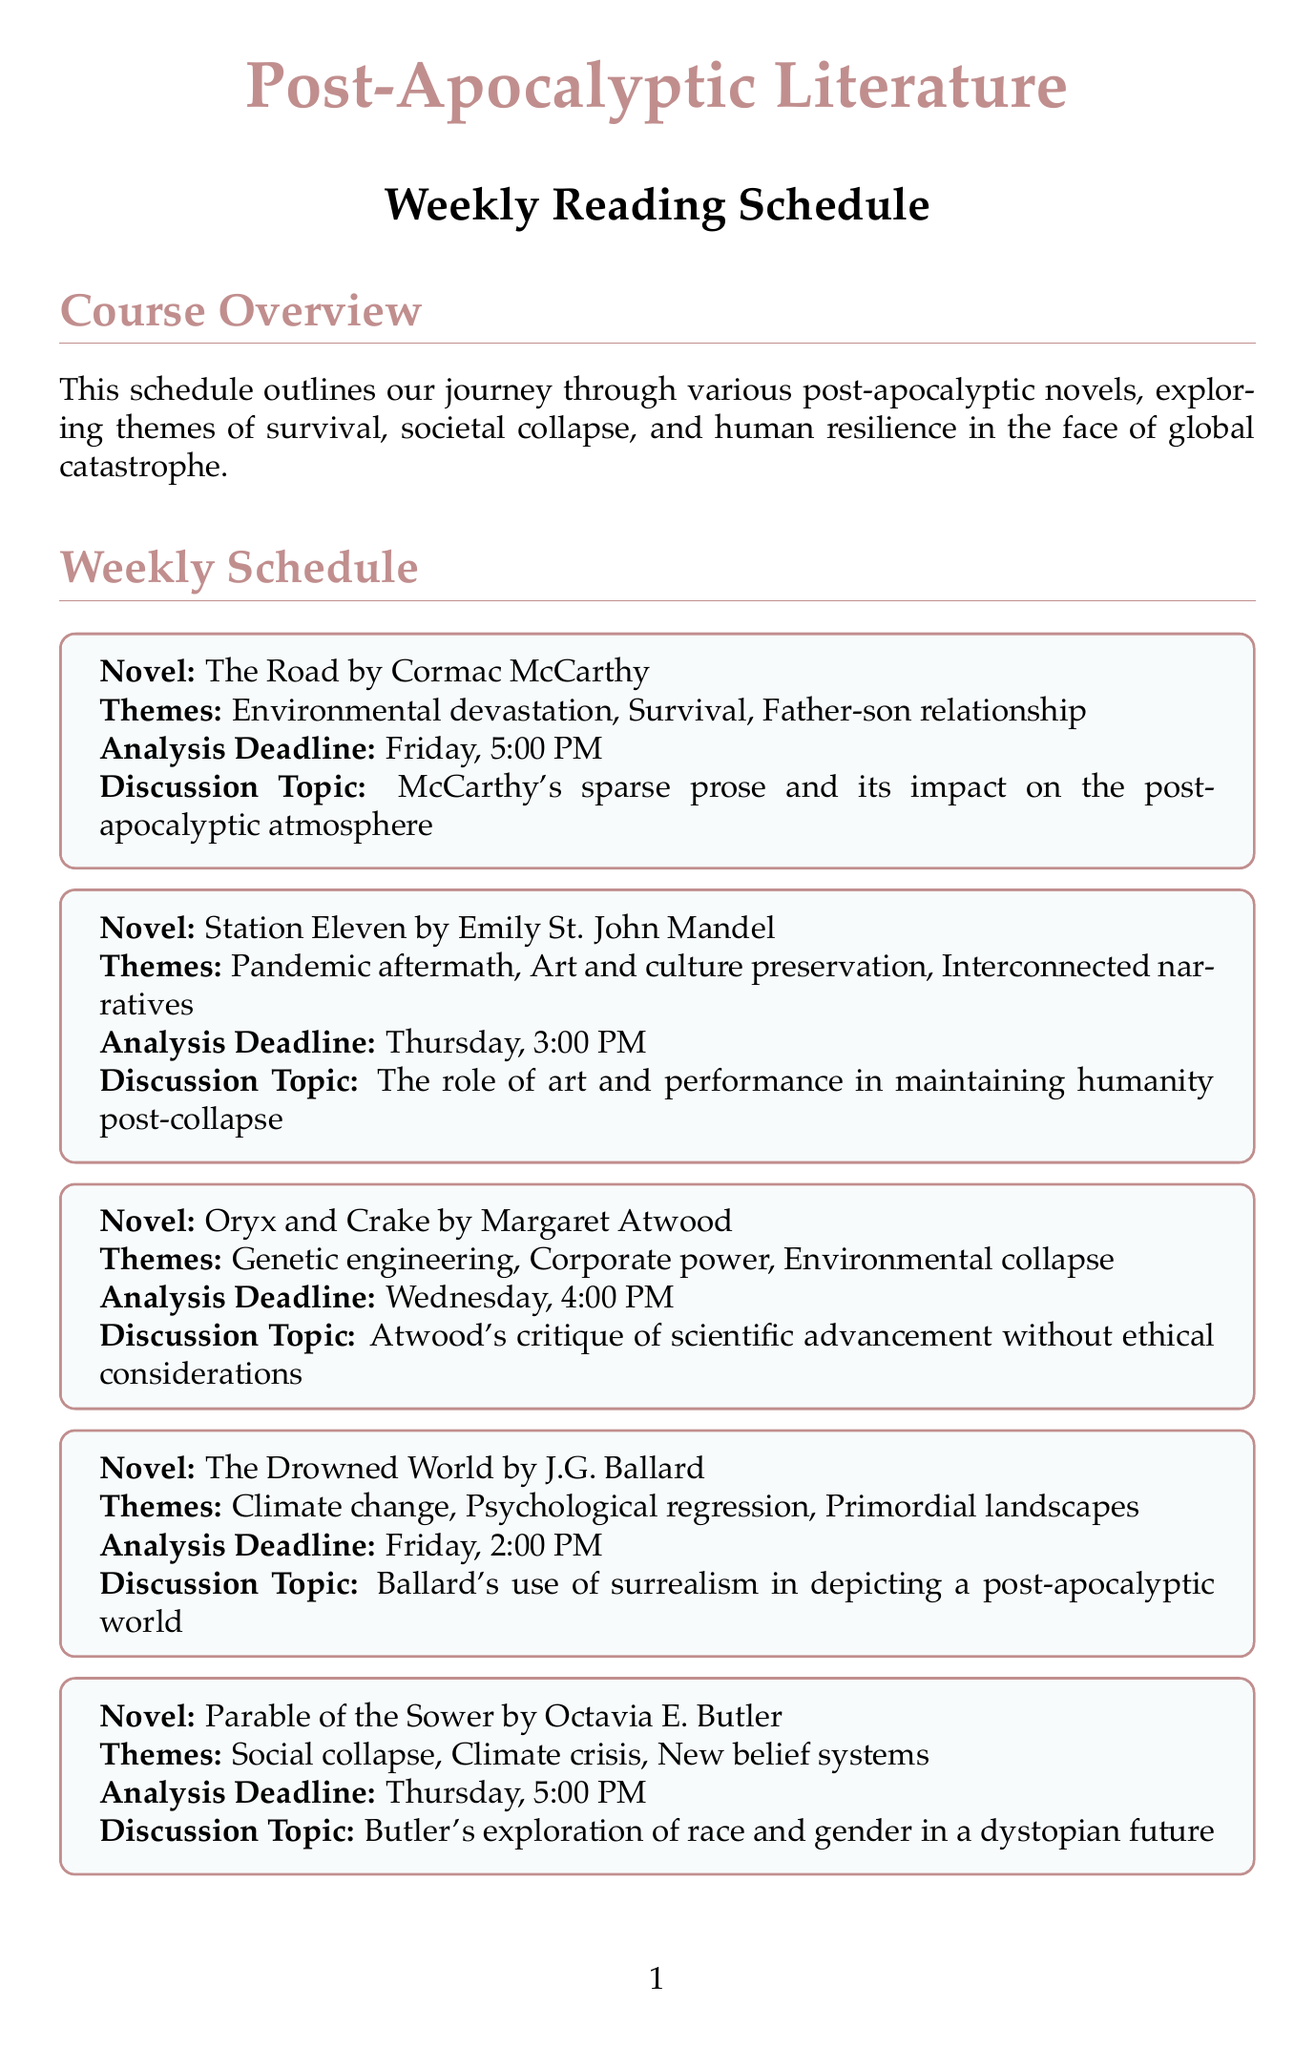what novel is assigned for week 1? The document lists "The Road by Cormac McCarthy" as the novel for week 1.
Answer: The Road by Cormac McCarthy what is the analysis deadline for "Station Eleven"? The document specifies that the analysis deadline for "Station Eleven" is Thursday, 3:00 PM.
Answer: Thursday, 3:00 PM which theme is associated with "The Handmaid's Tale"? "The Handmaid's Tale" is associated with themes such as gender oppression, religious extremism, and reproductive rights.
Answer: Gender oppression what is the discussion topic for "The Chrysalids"? The discussion topic listed for "The Chrysalids" is about Wyndham's exploration of prejudice and evolution in a post-nuclear world.
Answer: Wyndham's exploration of prejudice and evolution in a post-nuclear world how many novels are listed in the weekly reading schedule? The document contains a total of 10 novels in the weekly reading schedule.
Answer: 10 what day is the analysis deadline for "Parable of the Sower"? The analysis deadline for "Parable of the Sower" is on Thursday.
Answer: Thursday which author wrote "The Stand"? The document identifies Stephen King as the author of "The Stand".
Answer: Stephen King what major theme is explored in "Oryx and Crake"? The major themes explored in "Oryx and Crake" include genetic engineering, corporate power, and environmental collapse.
Answer: Genetic engineering which week features a novel discussing climate change? "The Drowned World" by J.G. Ballard, discussing climate change, is featured in week 4.
Answer: Week 4 